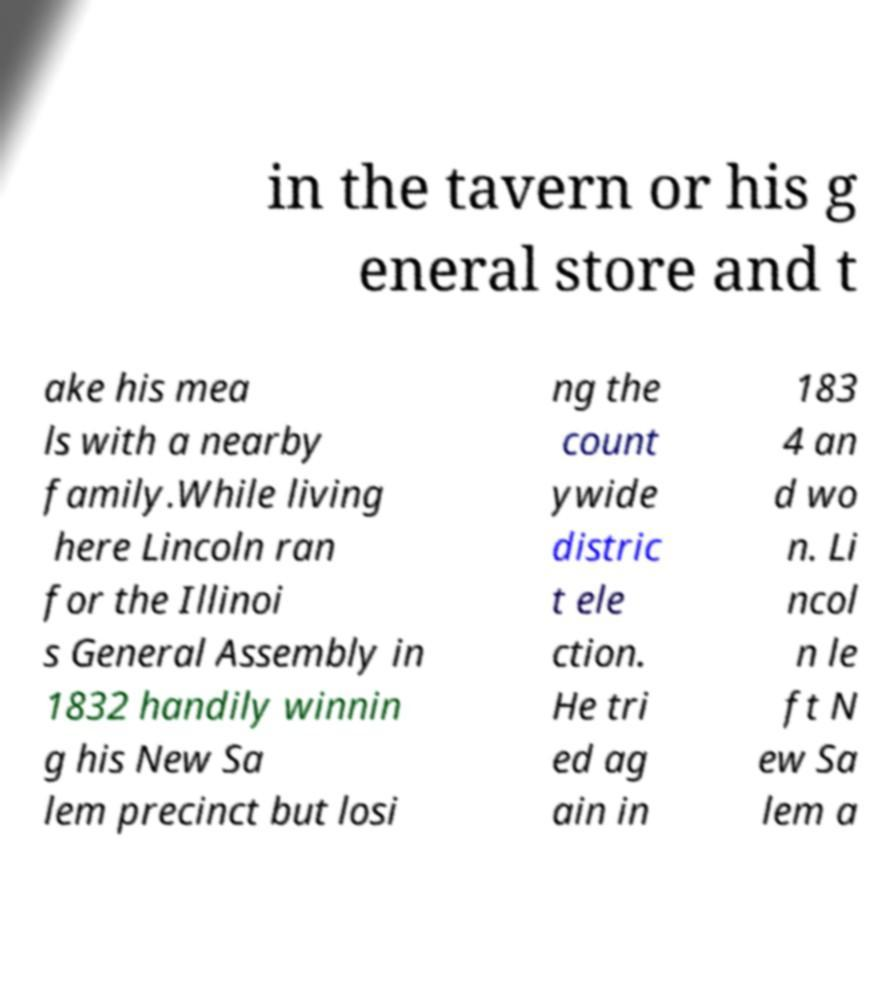I need the written content from this picture converted into text. Can you do that? in the tavern or his g eneral store and t ake his mea ls with a nearby family.While living here Lincoln ran for the Illinoi s General Assembly in 1832 handily winnin g his New Sa lem precinct but losi ng the count ywide distric t ele ction. He tri ed ag ain in 183 4 an d wo n. Li ncol n le ft N ew Sa lem a 